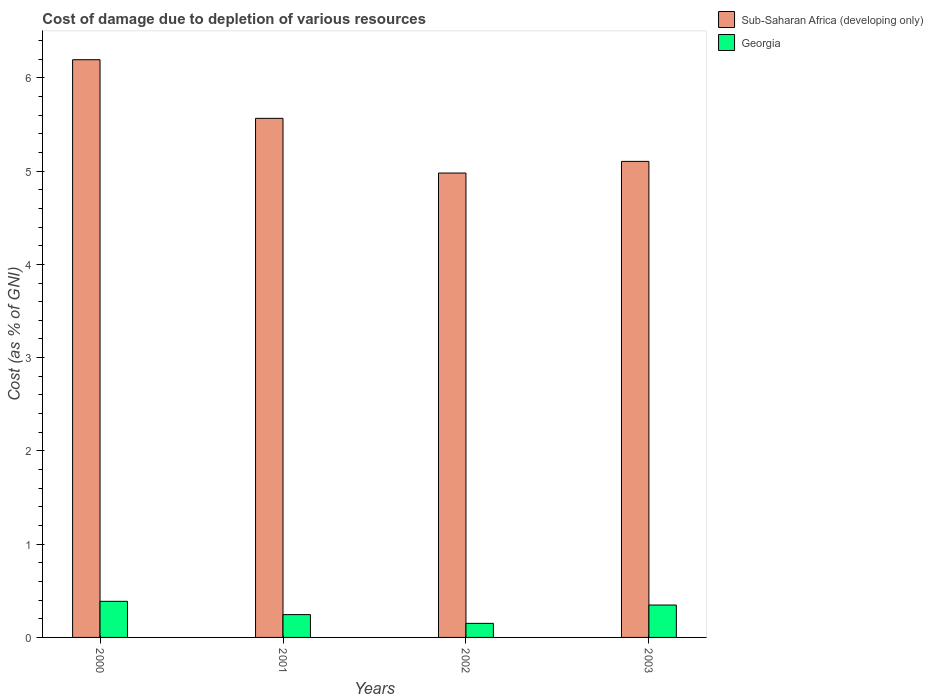How many groups of bars are there?
Your response must be concise. 4. Are the number of bars on each tick of the X-axis equal?
Offer a terse response. Yes. How many bars are there on the 1st tick from the left?
Give a very brief answer. 2. How many bars are there on the 1st tick from the right?
Provide a succinct answer. 2. What is the cost of damage caused due to the depletion of various resources in Sub-Saharan Africa (developing only) in 2003?
Your answer should be compact. 5.1. Across all years, what is the maximum cost of damage caused due to the depletion of various resources in Sub-Saharan Africa (developing only)?
Ensure brevity in your answer.  6.19. Across all years, what is the minimum cost of damage caused due to the depletion of various resources in Georgia?
Ensure brevity in your answer.  0.15. In which year was the cost of damage caused due to the depletion of various resources in Georgia maximum?
Your answer should be compact. 2000. What is the total cost of damage caused due to the depletion of various resources in Sub-Saharan Africa (developing only) in the graph?
Keep it short and to the point. 21.84. What is the difference between the cost of damage caused due to the depletion of various resources in Georgia in 2000 and that in 2001?
Make the answer very short. 0.14. What is the difference between the cost of damage caused due to the depletion of various resources in Georgia in 2000 and the cost of damage caused due to the depletion of various resources in Sub-Saharan Africa (developing only) in 2001?
Your answer should be compact. -5.18. What is the average cost of damage caused due to the depletion of various resources in Georgia per year?
Provide a succinct answer. 0.28. In the year 2000, what is the difference between the cost of damage caused due to the depletion of various resources in Georgia and cost of damage caused due to the depletion of various resources in Sub-Saharan Africa (developing only)?
Your answer should be compact. -5.81. In how many years, is the cost of damage caused due to the depletion of various resources in Sub-Saharan Africa (developing only) greater than 2.6 %?
Offer a terse response. 4. What is the ratio of the cost of damage caused due to the depletion of various resources in Sub-Saharan Africa (developing only) in 2002 to that in 2003?
Your answer should be very brief. 0.98. What is the difference between the highest and the second highest cost of damage caused due to the depletion of various resources in Sub-Saharan Africa (developing only)?
Your response must be concise. 0.63. What is the difference between the highest and the lowest cost of damage caused due to the depletion of various resources in Georgia?
Provide a short and direct response. 0.24. What does the 1st bar from the left in 2001 represents?
Ensure brevity in your answer.  Sub-Saharan Africa (developing only). What does the 2nd bar from the right in 2000 represents?
Your response must be concise. Sub-Saharan Africa (developing only). How many bars are there?
Keep it short and to the point. 8. How many years are there in the graph?
Your answer should be very brief. 4. Are the values on the major ticks of Y-axis written in scientific E-notation?
Your response must be concise. No. Does the graph contain any zero values?
Give a very brief answer. No. Does the graph contain grids?
Your answer should be very brief. No. How are the legend labels stacked?
Give a very brief answer. Vertical. What is the title of the graph?
Your response must be concise. Cost of damage due to depletion of various resources. What is the label or title of the X-axis?
Offer a very short reply. Years. What is the label or title of the Y-axis?
Provide a short and direct response. Cost (as % of GNI). What is the Cost (as % of GNI) in Sub-Saharan Africa (developing only) in 2000?
Provide a succinct answer. 6.19. What is the Cost (as % of GNI) of Georgia in 2000?
Your answer should be compact. 0.39. What is the Cost (as % of GNI) of Sub-Saharan Africa (developing only) in 2001?
Your response must be concise. 5.57. What is the Cost (as % of GNI) in Georgia in 2001?
Keep it short and to the point. 0.24. What is the Cost (as % of GNI) in Sub-Saharan Africa (developing only) in 2002?
Your answer should be compact. 4.98. What is the Cost (as % of GNI) in Georgia in 2002?
Your answer should be compact. 0.15. What is the Cost (as % of GNI) in Sub-Saharan Africa (developing only) in 2003?
Provide a succinct answer. 5.1. What is the Cost (as % of GNI) in Georgia in 2003?
Provide a short and direct response. 0.35. Across all years, what is the maximum Cost (as % of GNI) in Sub-Saharan Africa (developing only)?
Offer a terse response. 6.19. Across all years, what is the maximum Cost (as % of GNI) in Georgia?
Make the answer very short. 0.39. Across all years, what is the minimum Cost (as % of GNI) in Sub-Saharan Africa (developing only)?
Offer a terse response. 4.98. Across all years, what is the minimum Cost (as % of GNI) in Georgia?
Your response must be concise. 0.15. What is the total Cost (as % of GNI) of Sub-Saharan Africa (developing only) in the graph?
Offer a terse response. 21.84. What is the total Cost (as % of GNI) of Georgia in the graph?
Make the answer very short. 1.13. What is the difference between the Cost (as % of GNI) in Sub-Saharan Africa (developing only) in 2000 and that in 2001?
Keep it short and to the point. 0.63. What is the difference between the Cost (as % of GNI) in Georgia in 2000 and that in 2001?
Offer a terse response. 0.14. What is the difference between the Cost (as % of GNI) in Sub-Saharan Africa (developing only) in 2000 and that in 2002?
Give a very brief answer. 1.22. What is the difference between the Cost (as % of GNI) in Georgia in 2000 and that in 2002?
Make the answer very short. 0.24. What is the difference between the Cost (as % of GNI) of Sub-Saharan Africa (developing only) in 2000 and that in 2003?
Your response must be concise. 1.09. What is the difference between the Cost (as % of GNI) of Georgia in 2000 and that in 2003?
Your answer should be very brief. 0.04. What is the difference between the Cost (as % of GNI) of Sub-Saharan Africa (developing only) in 2001 and that in 2002?
Your response must be concise. 0.59. What is the difference between the Cost (as % of GNI) in Georgia in 2001 and that in 2002?
Provide a succinct answer. 0.09. What is the difference between the Cost (as % of GNI) in Sub-Saharan Africa (developing only) in 2001 and that in 2003?
Keep it short and to the point. 0.46. What is the difference between the Cost (as % of GNI) in Georgia in 2001 and that in 2003?
Give a very brief answer. -0.1. What is the difference between the Cost (as % of GNI) of Sub-Saharan Africa (developing only) in 2002 and that in 2003?
Ensure brevity in your answer.  -0.12. What is the difference between the Cost (as % of GNI) of Georgia in 2002 and that in 2003?
Your response must be concise. -0.2. What is the difference between the Cost (as % of GNI) in Sub-Saharan Africa (developing only) in 2000 and the Cost (as % of GNI) in Georgia in 2001?
Your response must be concise. 5.95. What is the difference between the Cost (as % of GNI) in Sub-Saharan Africa (developing only) in 2000 and the Cost (as % of GNI) in Georgia in 2002?
Your answer should be compact. 6.04. What is the difference between the Cost (as % of GNI) in Sub-Saharan Africa (developing only) in 2000 and the Cost (as % of GNI) in Georgia in 2003?
Give a very brief answer. 5.85. What is the difference between the Cost (as % of GNI) of Sub-Saharan Africa (developing only) in 2001 and the Cost (as % of GNI) of Georgia in 2002?
Provide a succinct answer. 5.41. What is the difference between the Cost (as % of GNI) in Sub-Saharan Africa (developing only) in 2001 and the Cost (as % of GNI) in Georgia in 2003?
Make the answer very short. 5.22. What is the difference between the Cost (as % of GNI) in Sub-Saharan Africa (developing only) in 2002 and the Cost (as % of GNI) in Georgia in 2003?
Give a very brief answer. 4.63. What is the average Cost (as % of GNI) in Sub-Saharan Africa (developing only) per year?
Ensure brevity in your answer.  5.46. What is the average Cost (as % of GNI) in Georgia per year?
Provide a short and direct response. 0.28. In the year 2000, what is the difference between the Cost (as % of GNI) in Sub-Saharan Africa (developing only) and Cost (as % of GNI) in Georgia?
Make the answer very short. 5.81. In the year 2001, what is the difference between the Cost (as % of GNI) of Sub-Saharan Africa (developing only) and Cost (as % of GNI) of Georgia?
Make the answer very short. 5.32. In the year 2002, what is the difference between the Cost (as % of GNI) in Sub-Saharan Africa (developing only) and Cost (as % of GNI) in Georgia?
Offer a very short reply. 4.83. In the year 2003, what is the difference between the Cost (as % of GNI) of Sub-Saharan Africa (developing only) and Cost (as % of GNI) of Georgia?
Give a very brief answer. 4.76. What is the ratio of the Cost (as % of GNI) in Sub-Saharan Africa (developing only) in 2000 to that in 2001?
Offer a very short reply. 1.11. What is the ratio of the Cost (as % of GNI) in Georgia in 2000 to that in 2001?
Ensure brevity in your answer.  1.58. What is the ratio of the Cost (as % of GNI) in Sub-Saharan Africa (developing only) in 2000 to that in 2002?
Provide a short and direct response. 1.24. What is the ratio of the Cost (as % of GNI) in Georgia in 2000 to that in 2002?
Give a very brief answer. 2.57. What is the ratio of the Cost (as % of GNI) of Sub-Saharan Africa (developing only) in 2000 to that in 2003?
Provide a short and direct response. 1.21. What is the ratio of the Cost (as % of GNI) of Georgia in 2000 to that in 2003?
Make the answer very short. 1.11. What is the ratio of the Cost (as % of GNI) of Sub-Saharan Africa (developing only) in 2001 to that in 2002?
Make the answer very short. 1.12. What is the ratio of the Cost (as % of GNI) of Georgia in 2001 to that in 2002?
Give a very brief answer. 1.62. What is the ratio of the Cost (as % of GNI) of Sub-Saharan Africa (developing only) in 2001 to that in 2003?
Provide a short and direct response. 1.09. What is the ratio of the Cost (as % of GNI) in Georgia in 2001 to that in 2003?
Offer a terse response. 0.7. What is the ratio of the Cost (as % of GNI) in Sub-Saharan Africa (developing only) in 2002 to that in 2003?
Your answer should be very brief. 0.98. What is the ratio of the Cost (as % of GNI) in Georgia in 2002 to that in 2003?
Provide a short and direct response. 0.43. What is the difference between the highest and the second highest Cost (as % of GNI) of Sub-Saharan Africa (developing only)?
Offer a terse response. 0.63. What is the difference between the highest and the second highest Cost (as % of GNI) of Georgia?
Ensure brevity in your answer.  0.04. What is the difference between the highest and the lowest Cost (as % of GNI) of Sub-Saharan Africa (developing only)?
Provide a short and direct response. 1.22. What is the difference between the highest and the lowest Cost (as % of GNI) in Georgia?
Your answer should be very brief. 0.24. 